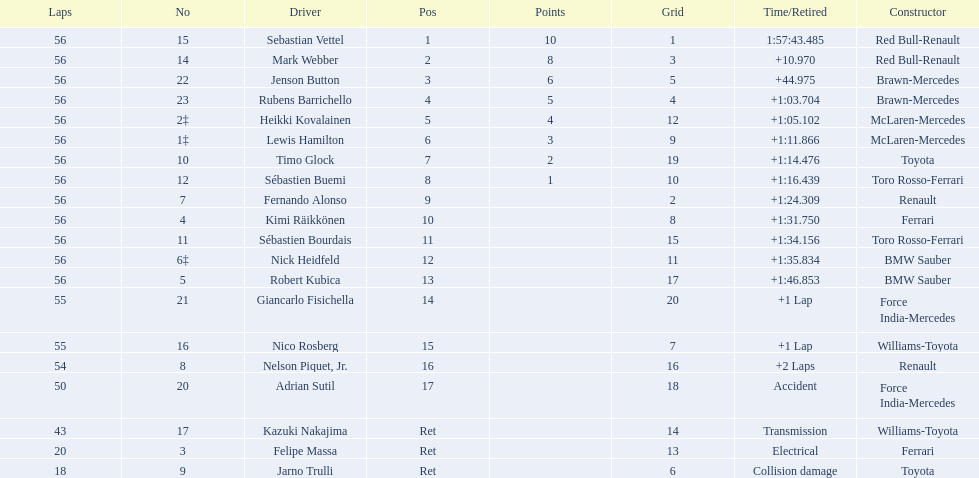Which drivers raced in the 2009 chinese grand prix? Sebastian Vettel, Mark Webber, Jenson Button, Rubens Barrichello, Heikki Kovalainen, Lewis Hamilton, Timo Glock, Sébastien Buemi, Fernando Alonso, Kimi Räikkönen, Sébastien Bourdais, Nick Heidfeld, Robert Kubica, Giancarlo Fisichella, Nico Rosberg, Nelson Piquet, Jr., Adrian Sutil, Kazuki Nakajima, Felipe Massa, Jarno Trulli. Of the drivers in the 2009 chinese grand prix, which finished the race? Sebastian Vettel, Mark Webber, Jenson Button, Rubens Barrichello, Heikki Kovalainen, Lewis Hamilton, Timo Glock, Sébastien Buemi, Fernando Alonso, Kimi Räikkönen, Sébastien Bourdais, Nick Heidfeld, Robert Kubica. Of the drivers who finished the race, who had the slowest time? Robert Kubica. Can you give me this table as a dict? {'header': ['Laps', 'No', 'Driver', 'Pos', 'Points', 'Grid', 'Time/Retired', 'Constructor'], 'rows': [['56', '15', 'Sebastian Vettel', '1', '10', '1', '1:57:43.485', 'Red Bull-Renault'], ['56', '14', 'Mark Webber', '2', '8', '3', '+10.970', 'Red Bull-Renault'], ['56', '22', 'Jenson Button', '3', '6', '5', '+44.975', 'Brawn-Mercedes'], ['56', '23', 'Rubens Barrichello', '4', '5', '4', '+1:03.704', 'Brawn-Mercedes'], ['56', '2‡', 'Heikki Kovalainen', '5', '4', '12', '+1:05.102', 'McLaren-Mercedes'], ['56', '1‡', 'Lewis Hamilton', '6', '3', '9', '+1:11.866', 'McLaren-Mercedes'], ['56', '10', 'Timo Glock', '7', '2', '19', '+1:14.476', 'Toyota'], ['56', '12', 'Sébastien Buemi', '8', '1', '10', '+1:16.439', 'Toro Rosso-Ferrari'], ['56', '7', 'Fernando Alonso', '9', '', '2', '+1:24.309', 'Renault'], ['56', '4', 'Kimi Räikkönen', '10', '', '8', '+1:31.750', 'Ferrari'], ['56', '11', 'Sébastien Bourdais', '11', '', '15', '+1:34.156', 'Toro Rosso-Ferrari'], ['56', '6‡', 'Nick Heidfeld', '12', '', '11', '+1:35.834', 'BMW Sauber'], ['56', '5', 'Robert Kubica', '13', '', '17', '+1:46.853', 'BMW Sauber'], ['55', '21', 'Giancarlo Fisichella', '14', '', '20', '+1 Lap', 'Force India-Mercedes'], ['55', '16', 'Nico Rosberg', '15', '', '7', '+1 Lap', 'Williams-Toyota'], ['54', '8', 'Nelson Piquet, Jr.', '16', '', '16', '+2 Laps', 'Renault'], ['50', '20', 'Adrian Sutil', '17', '', '18', 'Accident', 'Force India-Mercedes'], ['43', '17', 'Kazuki Nakajima', 'Ret', '', '14', 'Transmission', 'Williams-Toyota'], ['20', '3', 'Felipe Massa', 'Ret', '', '13', 'Electrical', 'Ferrari'], ['18', '9', 'Jarno Trulli', 'Ret', '', '6', 'Collision damage', 'Toyota']]} 